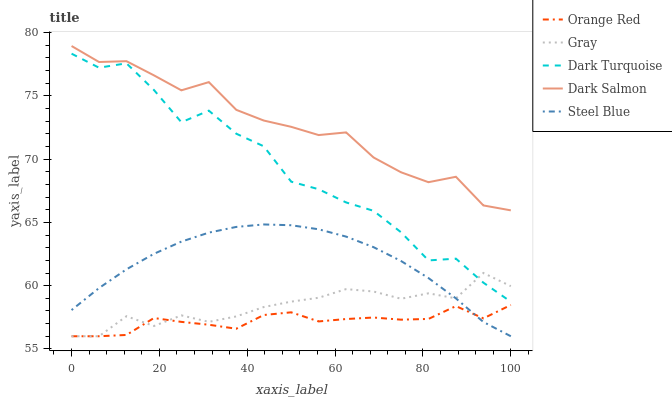Does Orange Red have the minimum area under the curve?
Answer yes or no. Yes. Does Dark Salmon have the maximum area under the curve?
Answer yes or no. Yes. Does Steel Blue have the minimum area under the curve?
Answer yes or no. No. Does Steel Blue have the maximum area under the curve?
Answer yes or no. No. Is Steel Blue the smoothest?
Answer yes or no. Yes. Is Dark Turquoise the roughest?
Answer yes or no. Yes. Is Dark Salmon the smoothest?
Answer yes or no. No. Is Dark Salmon the roughest?
Answer yes or no. No. Does Gray have the lowest value?
Answer yes or no. Yes. Does Dark Salmon have the lowest value?
Answer yes or no. No. Does Dark Salmon have the highest value?
Answer yes or no. Yes. Does Steel Blue have the highest value?
Answer yes or no. No. Is Steel Blue less than Dark Salmon?
Answer yes or no. Yes. Is Dark Salmon greater than Dark Turquoise?
Answer yes or no. Yes. Does Gray intersect Steel Blue?
Answer yes or no. Yes. Is Gray less than Steel Blue?
Answer yes or no. No. Is Gray greater than Steel Blue?
Answer yes or no. No. Does Steel Blue intersect Dark Salmon?
Answer yes or no. No. 